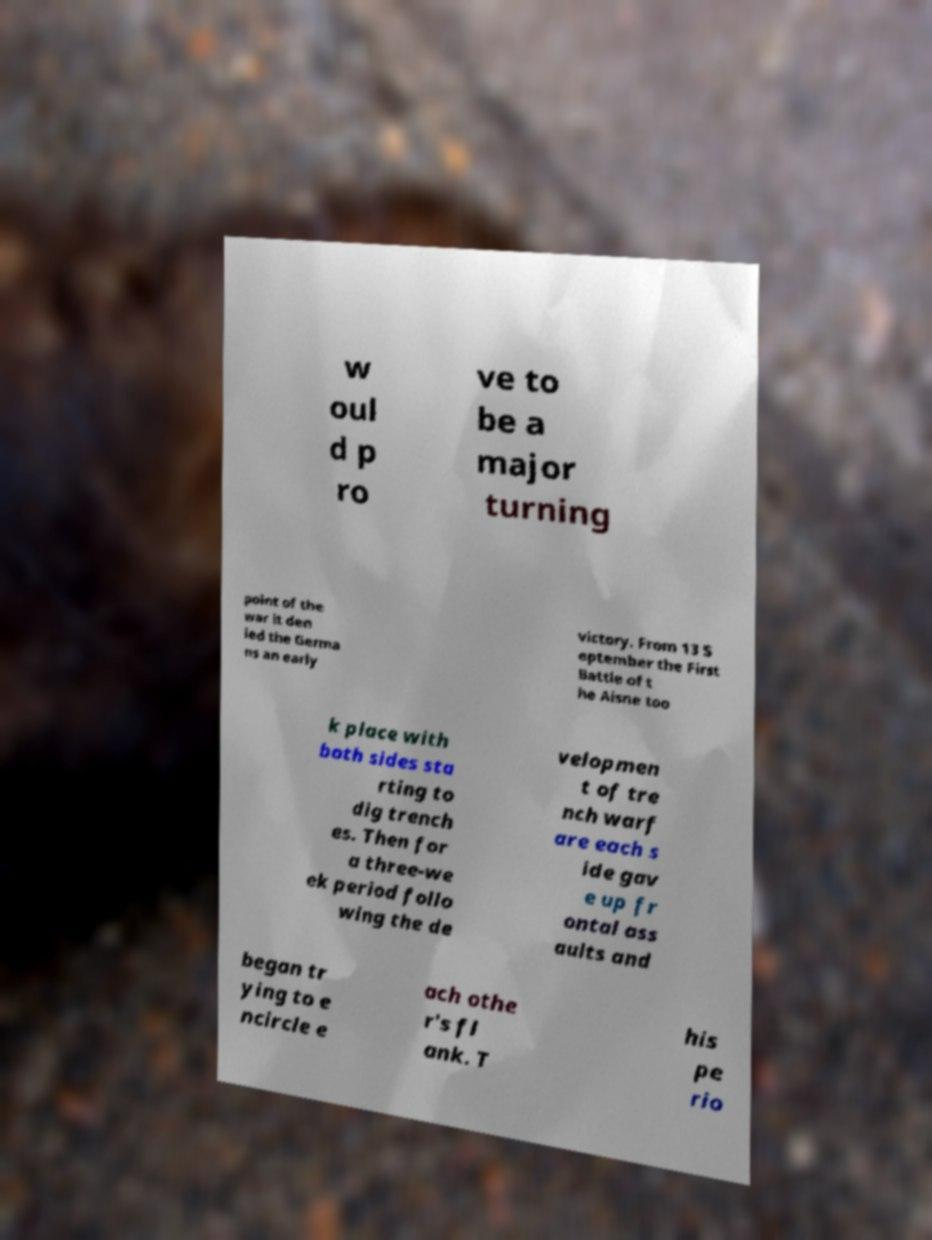There's text embedded in this image that I need extracted. Can you transcribe it verbatim? w oul d p ro ve to be a major turning point of the war it den ied the Germa ns an early victory. From 13 S eptember the First Battle of t he Aisne too k place with both sides sta rting to dig trench es. Then for a three-we ek period follo wing the de velopmen t of tre nch warf are each s ide gav e up fr ontal ass aults and began tr ying to e ncircle e ach othe r's fl ank. T his pe rio 